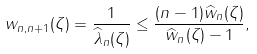<formula> <loc_0><loc_0><loc_500><loc_500>w _ { n , n + 1 } ( \zeta ) = \frac { 1 } { \widehat { \lambda } _ { n } ( \zeta ) } \leq \frac { ( n - 1 ) \widehat { w } _ { n } ( \zeta ) } { \widehat { w } _ { n } ( \zeta ) - 1 } ,</formula> 